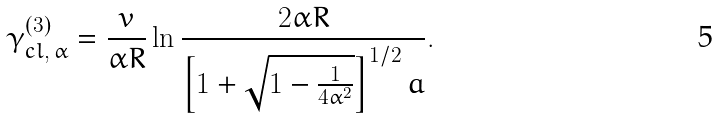<formula> <loc_0><loc_0><loc_500><loc_500>\gamma _ { c l , \, \alpha } ^ { ( 3 ) } = \frac { v } { \alpha R } \ln \frac { 2 \alpha R } { \left [ 1 + \sqrt { 1 - \frac { 1 } { 4 \alpha ^ { 2 } } } \right ] ^ { 1 / 2 } a } .</formula> 